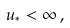<formula> <loc_0><loc_0><loc_500><loc_500>u _ { * } < \infty \, ,</formula> 